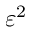<formula> <loc_0><loc_0><loc_500><loc_500>\varepsilon ^ { 2 }</formula> 